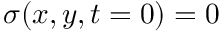Convert formula to latex. <formula><loc_0><loc_0><loc_500><loc_500>\sigma ( x , y , t = 0 ) = 0</formula> 